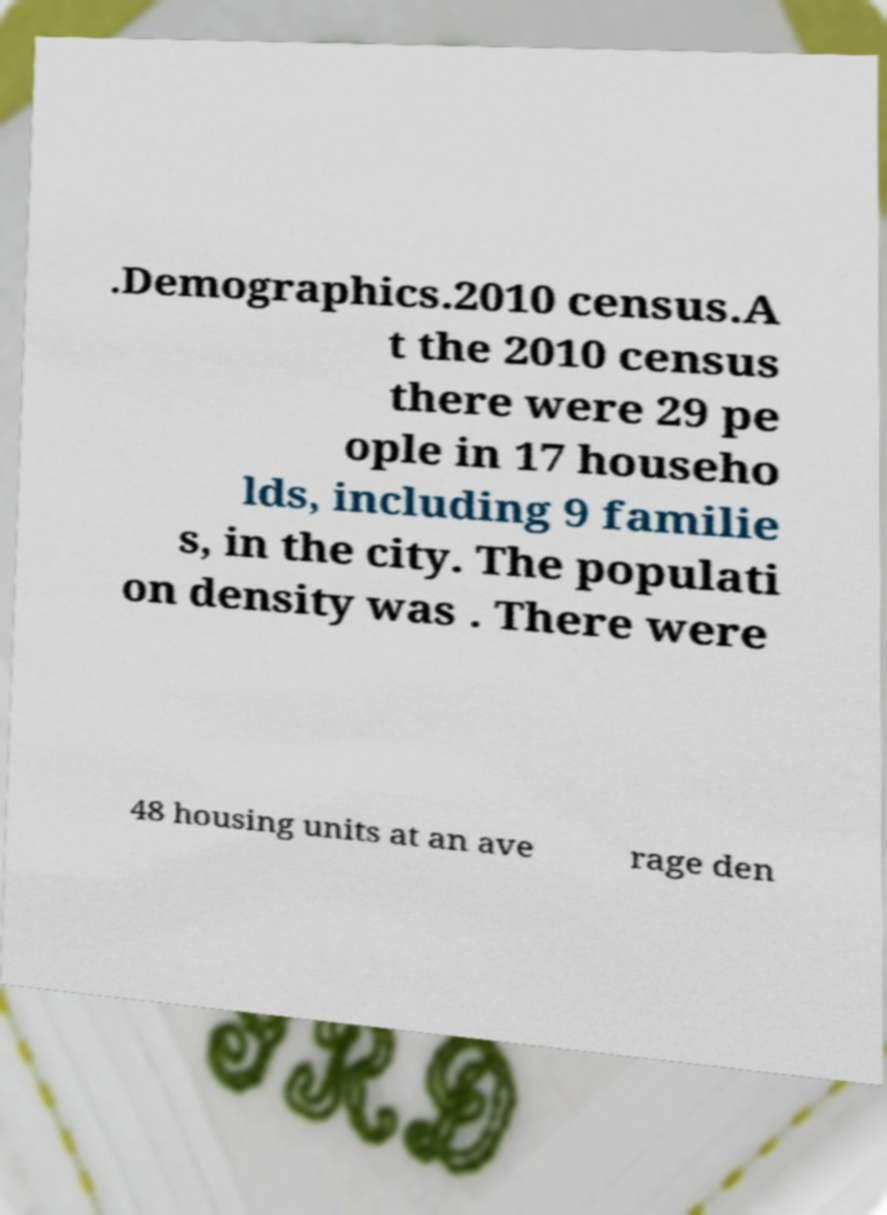I need the written content from this picture converted into text. Can you do that? .Demographics.2010 census.A t the 2010 census there were 29 pe ople in 17 househo lds, including 9 familie s, in the city. The populati on density was . There were 48 housing units at an ave rage den 